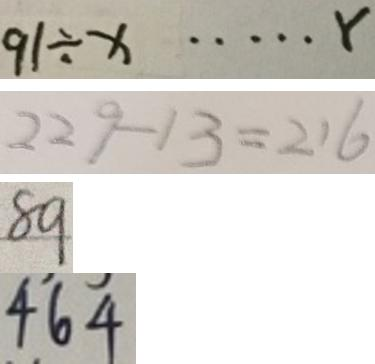<formula> <loc_0><loc_0><loc_500><loc_500>9 1 \div x \cdots r 
 2 2 9 - 1 3 = 2 1 6 
 8 9 
 4 6 4</formula> 